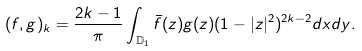Convert formula to latex. <formula><loc_0><loc_0><loc_500><loc_500>( f , g ) _ { k } = \frac { 2 k - 1 } { \pi } \int _ { \mathbb { D } _ { 1 } } \bar { f } ( z ) g ( z ) ( 1 - | z | ^ { 2 } ) ^ { 2 k - 2 } d x d y .</formula> 